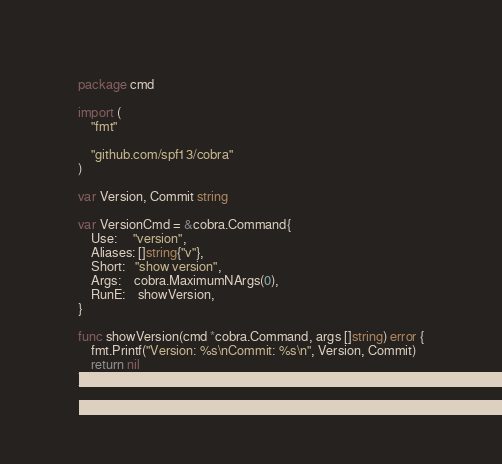<code> <loc_0><loc_0><loc_500><loc_500><_Go_>package cmd

import (
	"fmt"

	"github.com/spf13/cobra"
)

var Version, Commit string

var VersionCmd = &cobra.Command{
	Use:     "version",
	Aliases: []string{"v"},
	Short:   "show version",
	Args:    cobra.MaximumNArgs(0),
	RunE:    showVersion,
}

func showVersion(cmd *cobra.Command, args []string) error {
	fmt.Printf("Version: %s\nCommit: %s\n", Version, Commit)
	return nil
}
</code> 